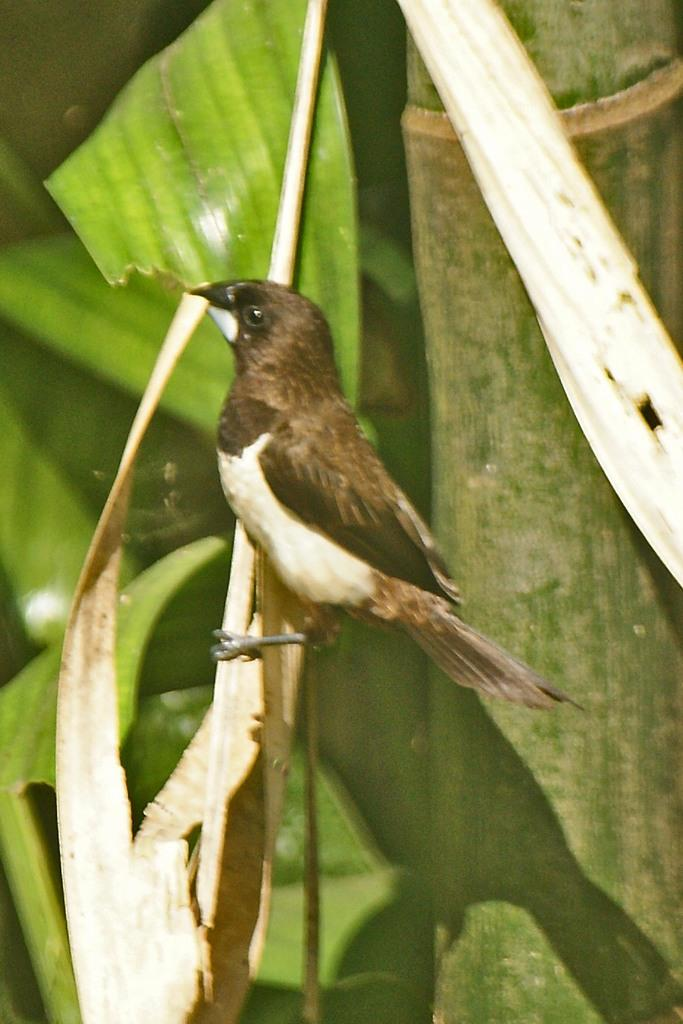What is the main subject in the center of the image? There is a bird in the center of the image. What is the bird resting on? The bird is on a stem. What can be seen in the background of the image? There is a tree in the background of the image. How many snakes are slithering down the alley in the image? There are no snakes or alleys present in the image; it features a bird on a stem with a tree in the background. 